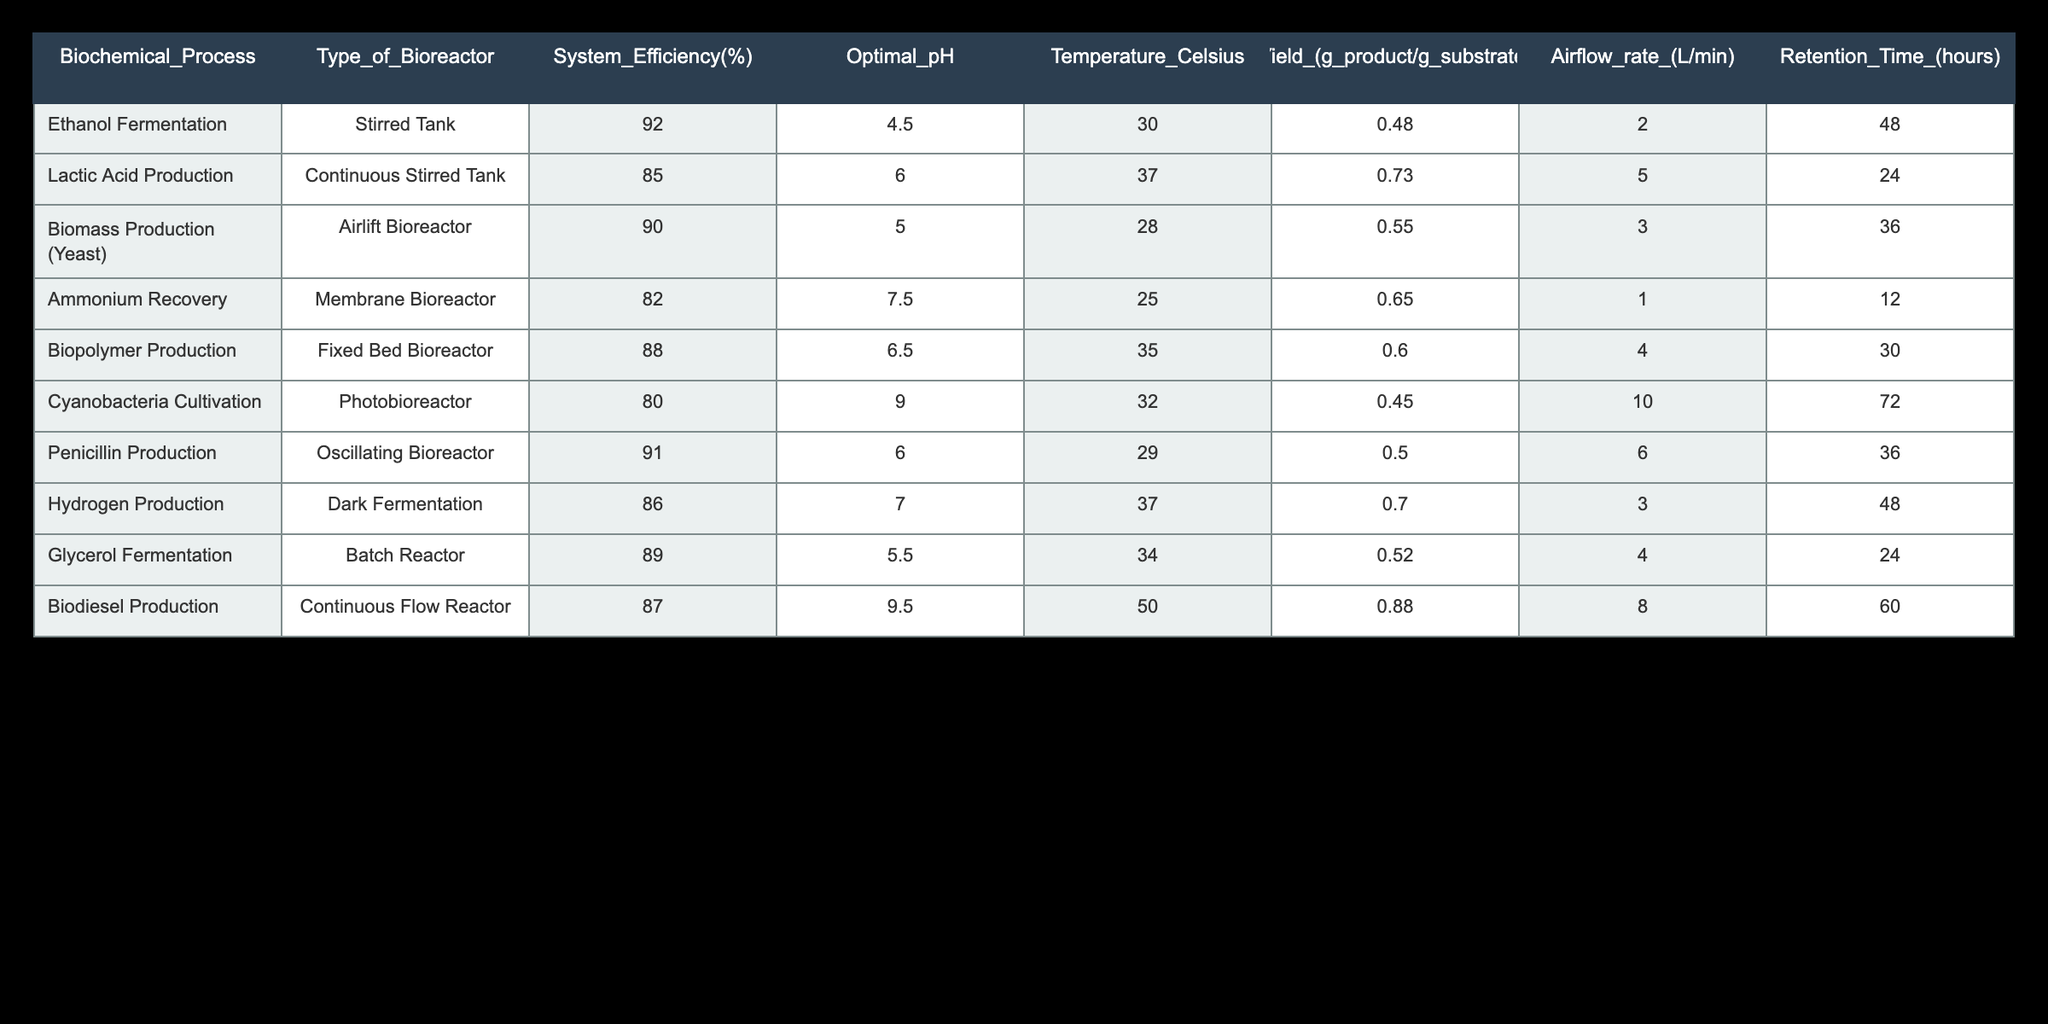What is the system efficiency of Hydrogen Production? The table specifies different biochemical processes and their respective system efficiencies. By locating the row for Hydrogen Production, we find the efficiency listed there is 86%.
Answer: 86% Which bioreactor has the highest system efficiency? To find the highest system efficiency, I compare all the values listed in the System Efficiency column. The highest value is 92%, which corresponds to Ethanol Fermentation using a Stirred Tank.
Answer: Ethanol Fermentation What is the average yield for all biochemical processes? To calculate the average yield, I first sum the yield values: (0.48 + 0.73 + 0.55 + 0.65 + 0.60 + 0.45 + 0.50 + 0.70 + 0.52 + 0.88) = 5.16. Then, I divide by the number of processes, which is 10: 5.16 / 10 = 0.516.
Answer: 0.516 Is the optimal pH for Biomass Production higher than for Lactic Acid Production? Looking at the Optimal pH values, Biomass Production has a pH of 5.0 while Lactic Acid Production has a pH of 6.0. Since 5.0 is lower than 6.0, the statement is false.
Answer: No How does the retention time for Cyanobacteria Cultivation compare to Penicillin Production? Cyanobacteria Cultivation has a retention time of 72 hours, whereas Penicillin Production has a retention time of 36 hours. Comparing these two values, I find that Cyanobacteria Cultivation has a longer retention time.
Answer: Longer What is the total airflow rate for all the bioreactors? To find the total airflow rate, I sum the airflow rates of all processes: (2 + 5 + 3 + 1 + 4 + 10 + 6 + 3 + 4 + 8) = 46 L/min.
Answer: 46 L/min Is it true that all bioreactors have an optimal temperature below 40 degrees Celsius? Examining the Temperature Celsius column, I see that Biodiesel Production has an optimal temperature of 50 degrees Celsius. Thus, not all bioreactors meet the criterion of being below 40 degrees Celsius.
Answer: No What is the difference in system efficiency between the Fixed Bed Bioreactor and the Dark Fermentation? The system efficiency for the Fixed Bed Bioreactor is 88%, while it is 86% for Dark Fermentation. The difference is 88% - 86% = 2%.
Answer: 2% 